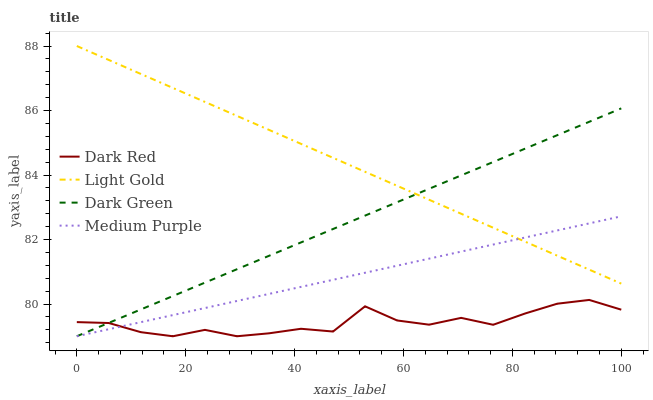Does Dark Red have the minimum area under the curve?
Answer yes or no. Yes. Does Light Gold have the maximum area under the curve?
Answer yes or no. Yes. Does Light Gold have the minimum area under the curve?
Answer yes or no. No. Does Dark Red have the maximum area under the curve?
Answer yes or no. No. Is Dark Green the smoothest?
Answer yes or no. Yes. Is Dark Red the roughest?
Answer yes or no. Yes. Is Light Gold the smoothest?
Answer yes or no. No. Is Light Gold the roughest?
Answer yes or no. No. Does Medium Purple have the lowest value?
Answer yes or no. Yes. Does Light Gold have the lowest value?
Answer yes or no. No. Does Light Gold have the highest value?
Answer yes or no. Yes. Does Dark Red have the highest value?
Answer yes or no. No. Is Dark Red less than Light Gold?
Answer yes or no. Yes. Is Light Gold greater than Dark Red?
Answer yes or no. Yes. Does Medium Purple intersect Light Gold?
Answer yes or no. Yes. Is Medium Purple less than Light Gold?
Answer yes or no. No. Is Medium Purple greater than Light Gold?
Answer yes or no. No. Does Dark Red intersect Light Gold?
Answer yes or no. No. 